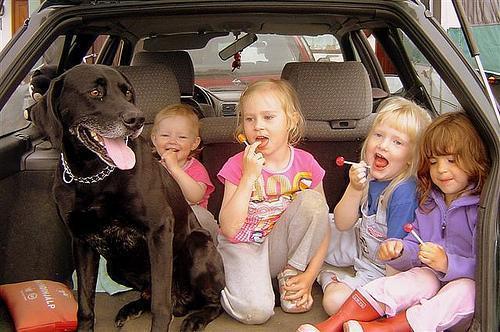How many kids are there?
Give a very brief answer. 4. How many people are there?
Give a very brief answer. 4. How many bikes are below the outdoor wall decorations?
Give a very brief answer. 0. 